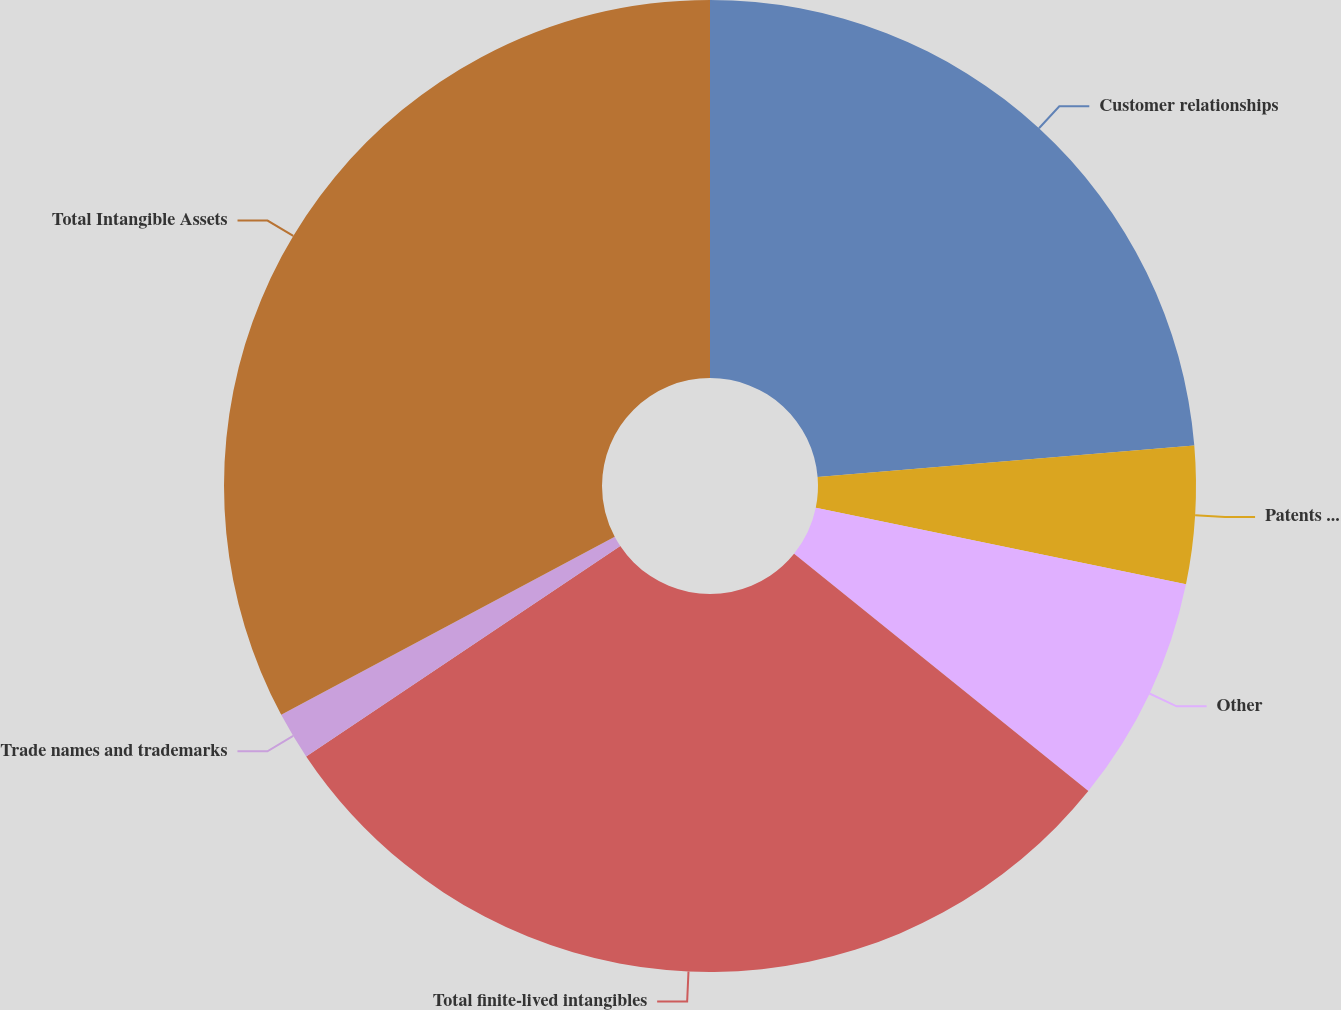Convert chart. <chart><loc_0><loc_0><loc_500><loc_500><pie_chart><fcel>Customer relationships<fcel>Patents and technology<fcel>Other<fcel>Total finite-lived intangibles<fcel>Trade names and trademarks<fcel>Total Intangible Assets<nl><fcel>23.67%<fcel>4.57%<fcel>7.56%<fcel>29.81%<fcel>1.59%<fcel>32.8%<nl></chart> 